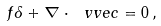<formula> <loc_0><loc_0><loc_500><loc_500>f \delta + { \nabla } \cdot \ v v e c = 0 \, ,</formula> 